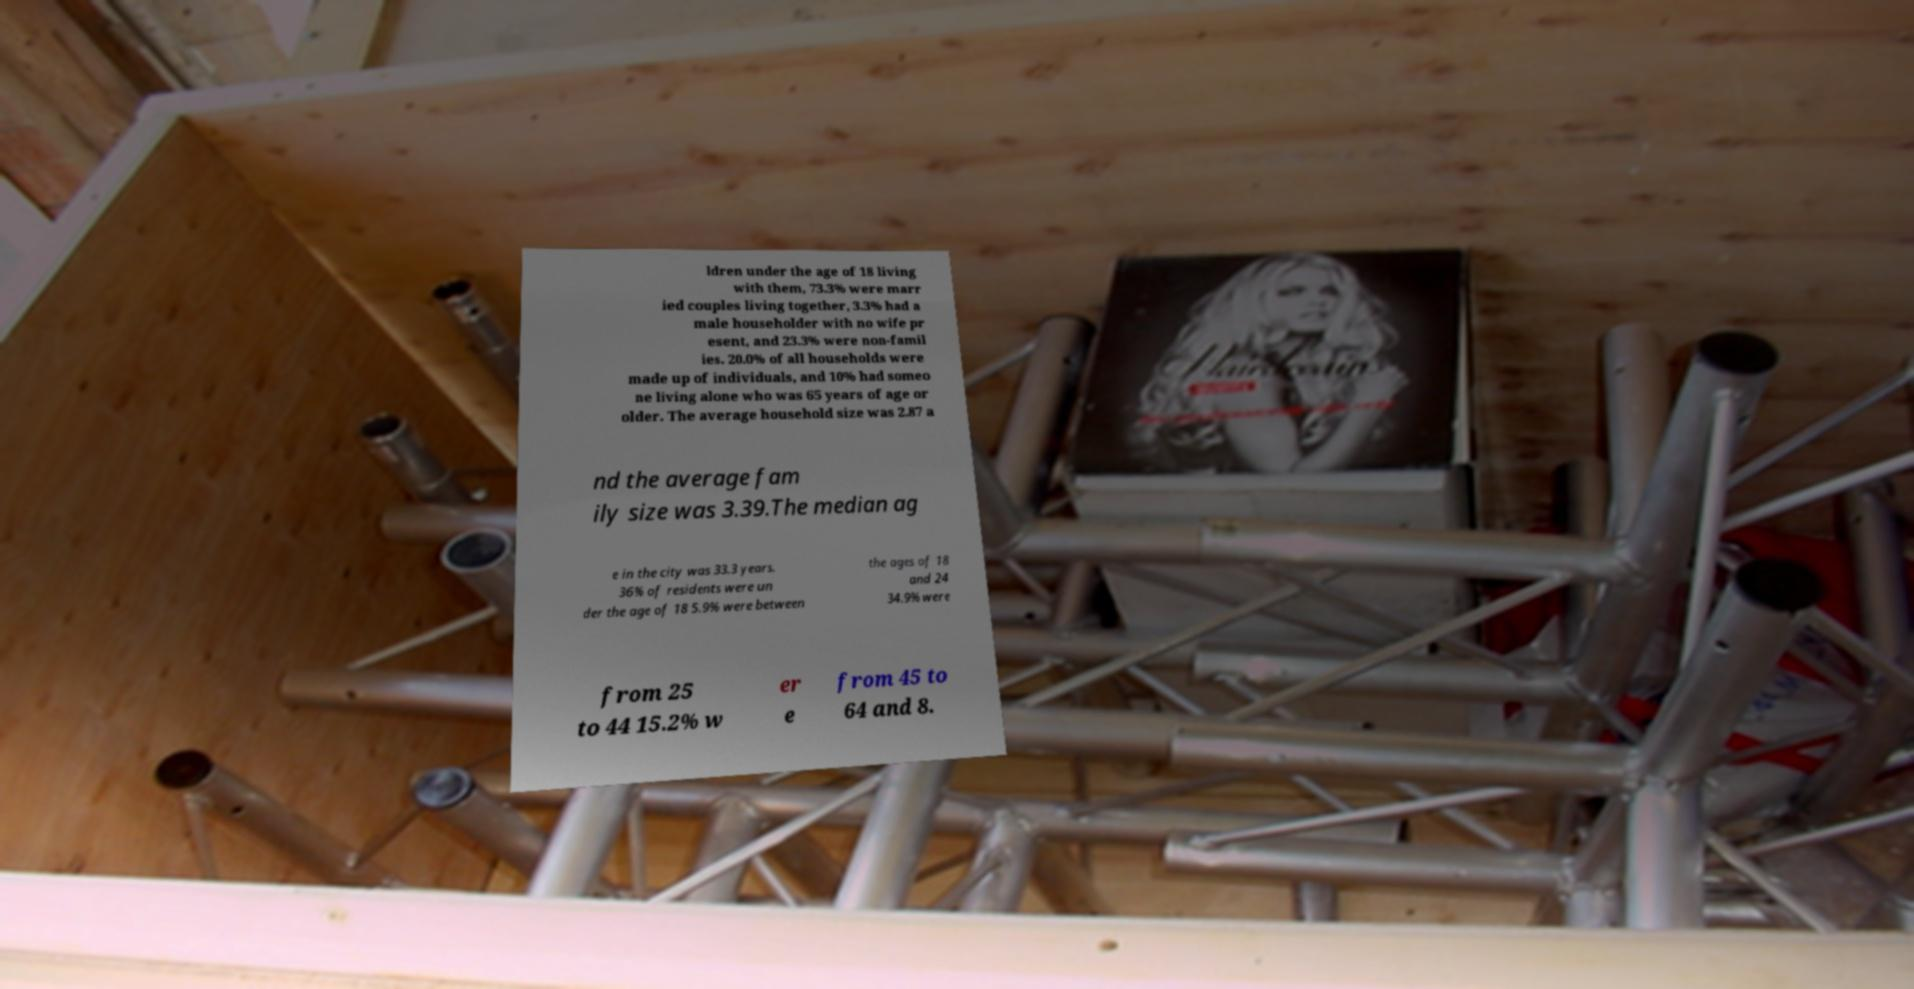Can you read and provide the text displayed in the image?This photo seems to have some interesting text. Can you extract and type it out for me? ldren under the age of 18 living with them, 73.3% were marr ied couples living together, 3.3% had a male householder with no wife pr esent, and 23.3% were non-famil ies. 20.0% of all households were made up of individuals, and 10% had someo ne living alone who was 65 years of age or older. The average household size was 2.87 a nd the average fam ily size was 3.39.The median ag e in the city was 33.3 years. 36% of residents were un der the age of 18 5.9% were between the ages of 18 and 24 34.9% were from 25 to 44 15.2% w er e from 45 to 64 and 8. 